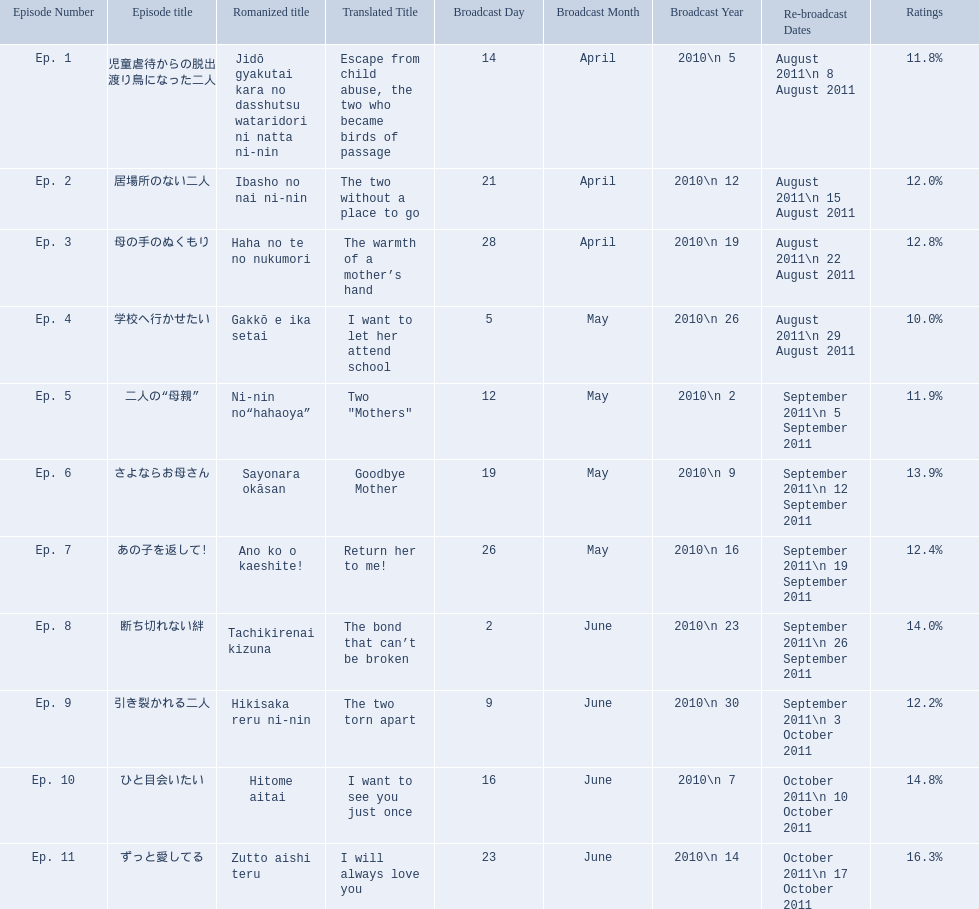What is the name of epsiode 8? 断ち切れない絆. What were this episodes ratings? 14.0%. 